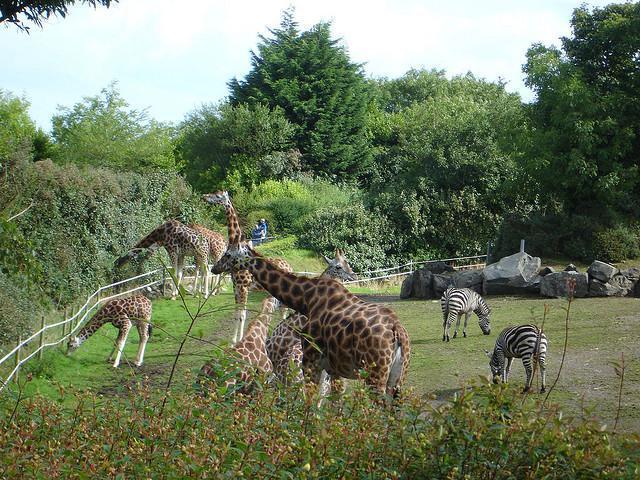How many animals are there?
Give a very brief answer. 8. How many people are visible?
Give a very brief answer. 0. How many giraffes are there?
Give a very brief answer. 6. How many boats can be seen in this image?
Give a very brief answer. 0. 